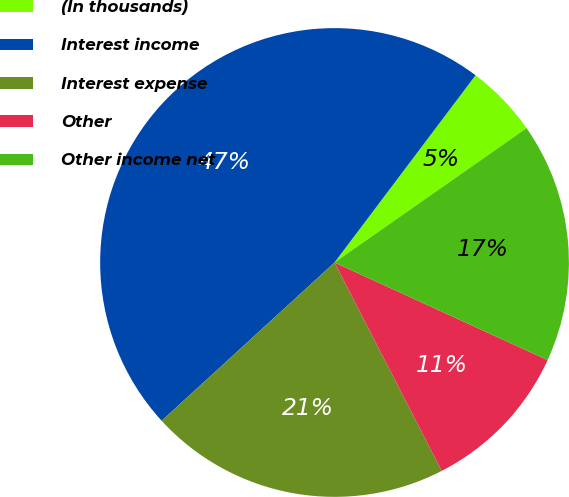Convert chart. <chart><loc_0><loc_0><loc_500><loc_500><pie_chart><fcel>(In thousands)<fcel>Interest income<fcel>Interest expense<fcel>Other<fcel>Other income net<nl><fcel>5.01%<fcel>47.07%<fcel>20.76%<fcel>10.6%<fcel>16.55%<nl></chart> 